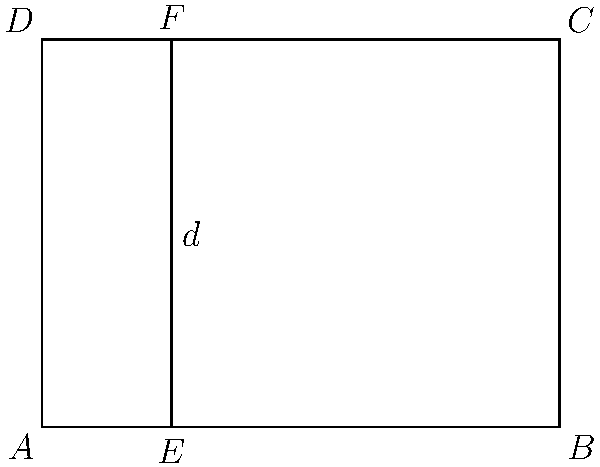In a parallel plate capacitor, two congruent rectangular plates are separated by a distance $d$. If the area of each plate is doubled while maintaining their congruence and the same separation distance, how does the capacitance change? To answer this question, let's follow these steps:

1. Recall the formula for capacitance of a parallel plate capacitor:
   $$ C = \frac{\epsilon_0 A}{d} $$
   where $C$ is capacitance, $\epsilon_0$ is the permittivity of free space, $A$ is the area of the plates, and $d$ is the separation distance.

2. In this case, we're doubling the area $A$ while keeping $d$ constant. Let's call the new capacitance $C_{new}$:
   $$ C_{new} = \frac{\epsilon_0 (2A)}{d} $$

3. We can express this in terms of the original capacitance:
   $$ C_{new} = \frac{\epsilon_0 (2A)}{d} = 2 \cdot \frac{\epsilon_0 A}{d} = 2C $$

4. This shows that doubling the area while maintaining congruence and separation distance results in doubling the capacitance.

5. The relationship between the new and original capacitance can be expressed as:
   $$ C_{new} = 2C $$

Therefore, the capacitance doubles when the area of each congruent plate is doubled while maintaining the same separation distance.
Answer: The capacitance doubles. 